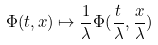Convert formula to latex. <formula><loc_0><loc_0><loc_500><loc_500>\Phi ( t , x ) \mapsto \frac { 1 } { \lambda } \Phi ( \frac { t } { \lambda } , \frac { x } { \lambda } )</formula> 